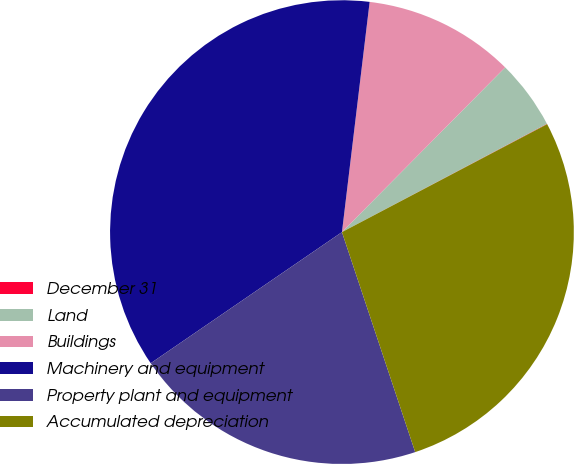<chart> <loc_0><loc_0><loc_500><loc_500><pie_chart><fcel>December 31<fcel>Land<fcel>Buildings<fcel>Machinery and equipment<fcel>Property plant and equipment<fcel>Accumulated depreciation<nl><fcel>0.03%<fcel>4.84%<fcel>10.52%<fcel>36.47%<fcel>20.55%<fcel>27.59%<nl></chart> 